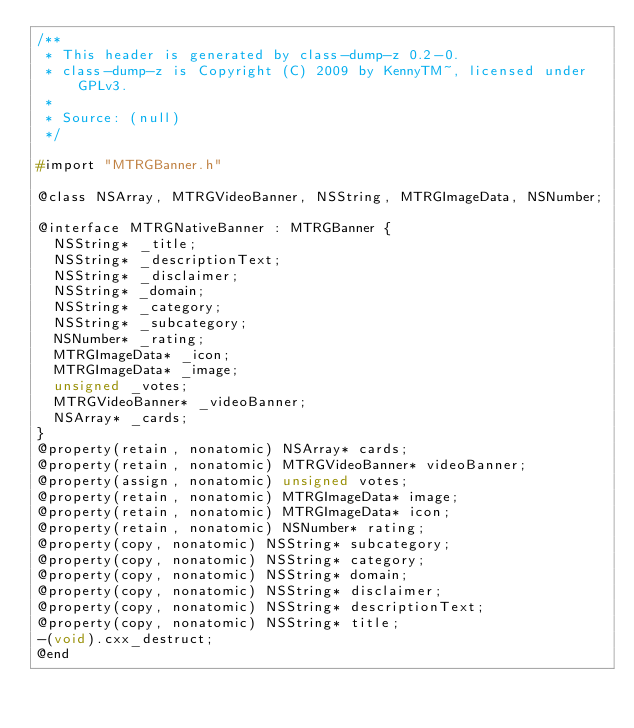<code> <loc_0><loc_0><loc_500><loc_500><_C_>/**
 * This header is generated by class-dump-z 0.2-0.
 * class-dump-z is Copyright (C) 2009 by KennyTM~, licensed under GPLv3.
 *
 * Source: (null)
 */

#import "MTRGBanner.h"

@class NSArray, MTRGVideoBanner, NSString, MTRGImageData, NSNumber;

@interface MTRGNativeBanner : MTRGBanner {
	NSString* _title;
	NSString* _descriptionText;
	NSString* _disclaimer;
	NSString* _domain;
	NSString* _category;
	NSString* _subcategory;
	NSNumber* _rating;
	MTRGImageData* _icon;
	MTRGImageData* _image;
	unsigned _votes;
	MTRGVideoBanner* _videoBanner;
	NSArray* _cards;
}
@property(retain, nonatomic) NSArray* cards;
@property(retain, nonatomic) MTRGVideoBanner* videoBanner;
@property(assign, nonatomic) unsigned votes;
@property(retain, nonatomic) MTRGImageData* image;
@property(retain, nonatomic) MTRGImageData* icon;
@property(retain, nonatomic) NSNumber* rating;
@property(copy, nonatomic) NSString* subcategory;
@property(copy, nonatomic) NSString* category;
@property(copy, nonatomic) NSString* domain;
@property(copy, nonatomic) NSString* disclaimer;
@property(copy, nonatomic) NSString* descriptionText;
@property(copy, nonatomic) NSString* title;
-(void).cxx_destruct;
@end

</code> 